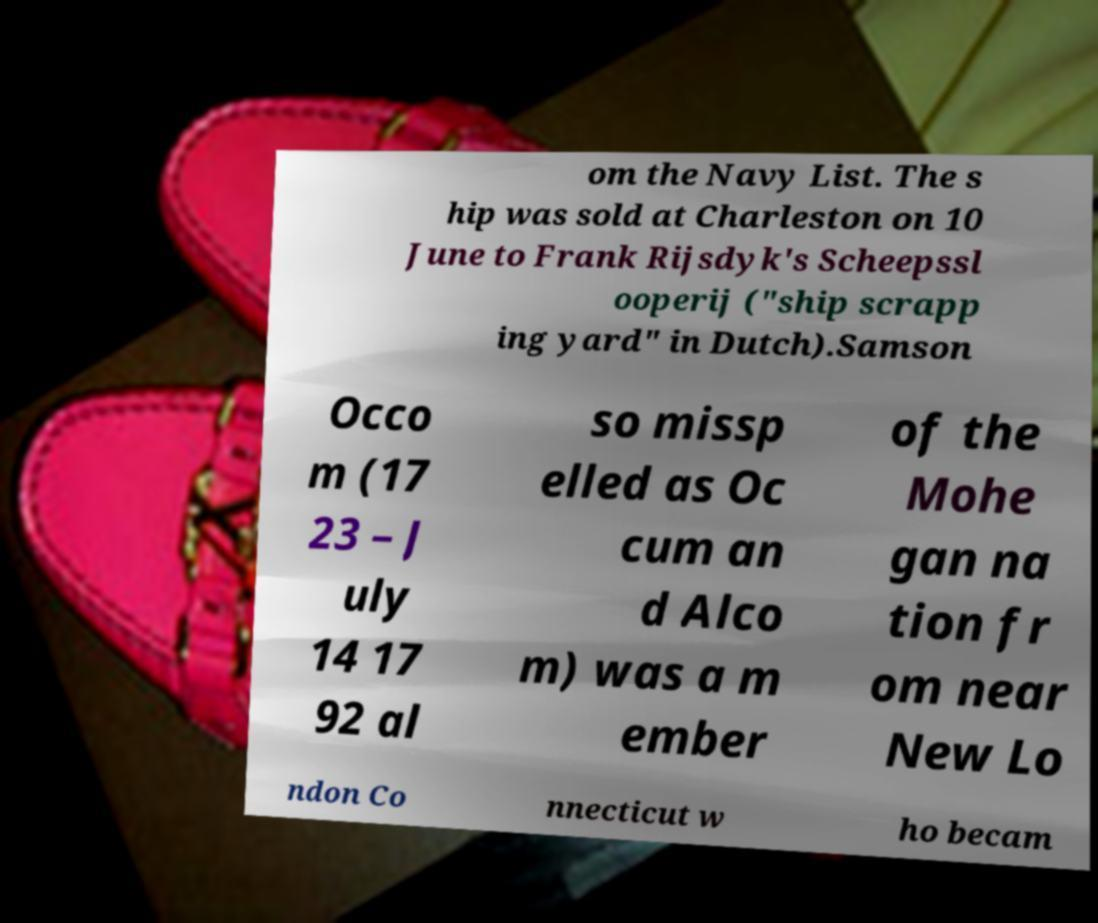For documentation purposes, I need the text within this image transcribed. Could you provide that? om the Navy List. The s hip was sold at Charleston on 10 June to Frank Rijsdyk's Scheepssl ooperij ("ship scrapp ing yard" in Dutch).Samson Occo m (17 23 – J uly 14 17 92 al so missp elled as Oc cum an d Alco m) was a m ember of the Mohe gan na tion fr om near New Lo ndon Co nnecticut w ho becam 